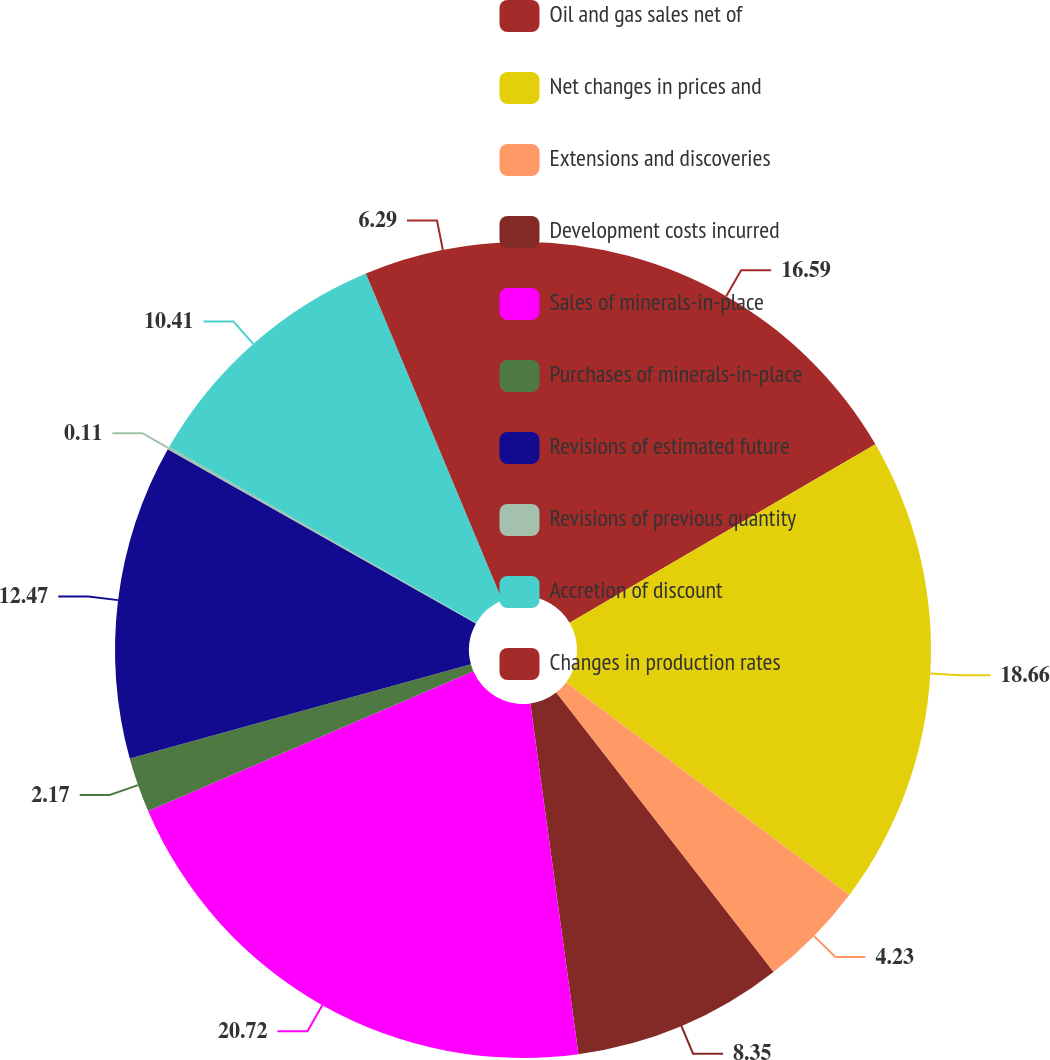<chart> <loc_0><loc_0><loc_500><loc_500><pie_chart><fcel>Oil and gas sales net of<fcel>Net changes in prices and<fcel>Extensions and discoveries<fcel>Development costs incurred<fcel>Sales of minerals-in-place<fcel>Purchases of minerals-in-place<fcel>Revisions of estimated future<fcel>Revisions of previous quantity<fcel>Accretion of discount<fcel>Changes in production rates<nl><fcel>16.59%<fcel>18.65%<fcel>4.23%<fcel>8.35%<fcel>20.71%<fcel>2.17%<fcel>12.47%<fcel>0.11%<fcel>10.41%<fcel>6.29%<nl></chart> 